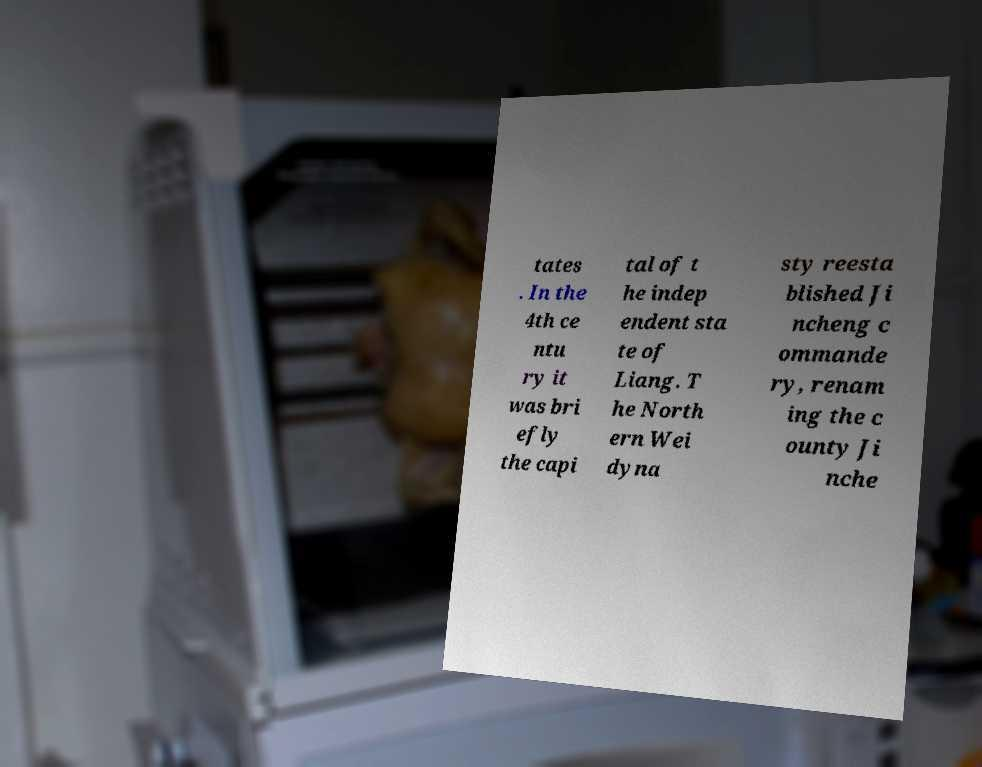Could you assist in decoding the text presented in this image and type it out clearly? tates . In the 4th ce ntu ry it was bri efly the capi tal of t he indep endent sta te of Liang. T he North ern Wei dyna sty reesta blished Ji ncheng c ommande ry, renam ing the c ounty Ji nche 